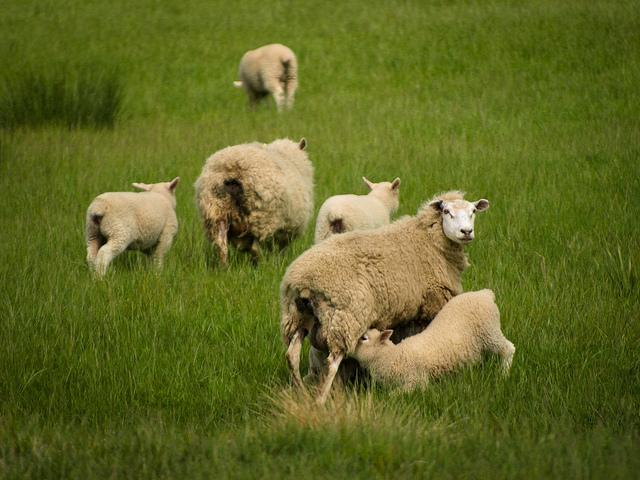What is the baby sheep doing? Please explain your reasoning. drinking. The sheep is drinking. 